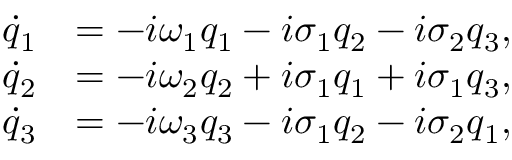<formula> <loc_0><loc_0><loc_500><loc_500>\begin{array} { r l } { \dot { q } _ { 1 } } & { = - i \omega _ { 1 } q _ { 1 } - i \sigma _ { 1 } q _ { 2 } - i \sigma _ { 2 } q _ { 3 } , } \\ { \dot { q } _ { 2 } } & { = - i \omega _ { 2 } q _ { 2 } + i \sigma _ { 1 } q _ { 1 } + i \sigma _ { 1 } q _ { 3 } , } \\ { \dot { q } _ { 3 } } & { = - i \omega _ { 3 } q _ { 3 } - i \sigma _ { 1 } q _ { 2 } - i \sigma _ { 2 } q _ { 1 } , } \end{array}</formula> 